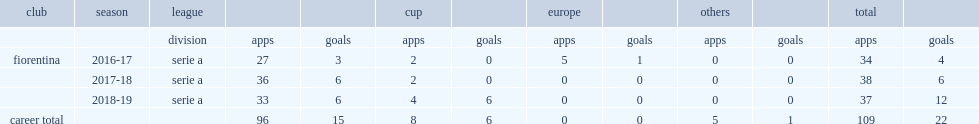Which league did federico chiesa make his debut for fiorentina in the 2016-17 season? Serie a. 